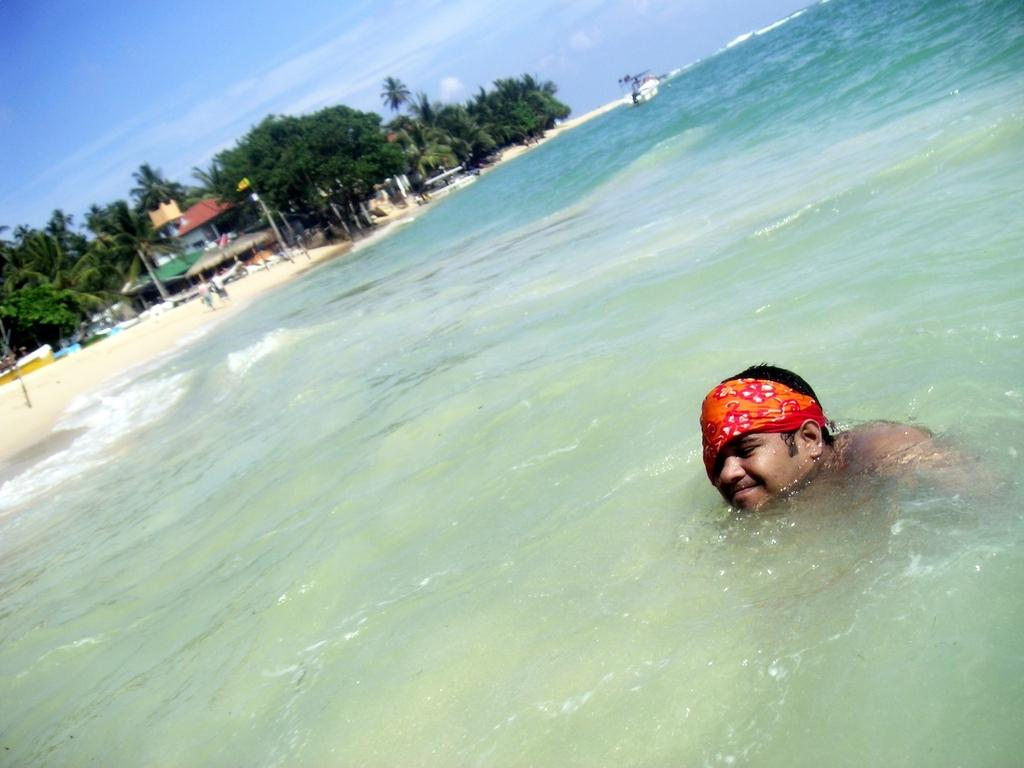Who or what is present in the image? There is a person in the image. What natural feature can be seen in the background? The ocean is visible in the image. What type of vegetation is present in the image? There are trees in the image. What else is visible in the sky? The sky is visible in the image. What type of temporary shelter can be seen on the left side of the image? There are tents on the left side of the image. What letters are being used to spell out a message on the tents in the image? There are no letters visible on the tents in the image; they are plain tents. How many cows can be seen grazing near the tents in the image? There are no cows present in the image. 